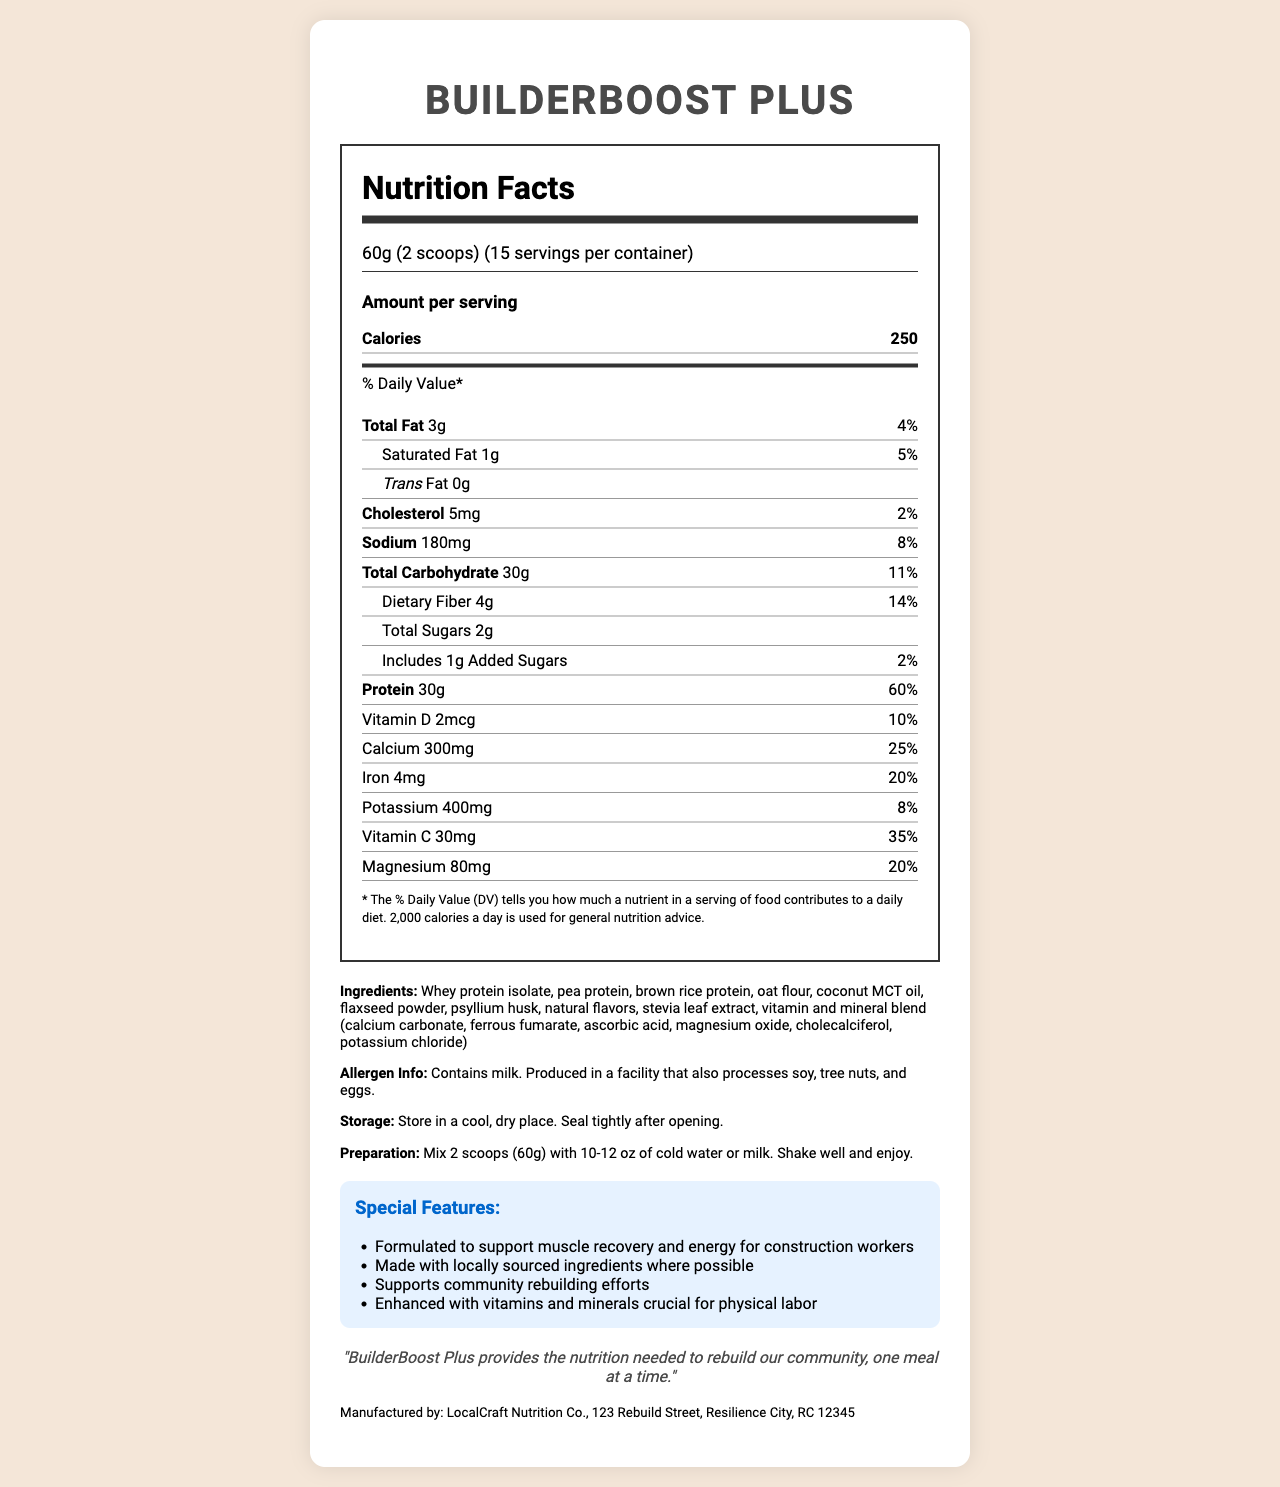what is the serving size of BuilderBoost Plus? The serving size is mentioned clearly in the document: "60g (2 scoops)."
Answer: 60g (2 scoops) how many calories does one serving of BuilderBoost Plus contain? The caloric content per serving is shown: "Calories 250."
Answer: 250 calories what is the amount of protein in BuilderBoost Plus per serving? The document specifies that each serving contains "Protein: 30g."
Answer: 30g what percentage of the daily value of Vitamin D does BuilderBoost Plus provide per serving? It is listed in the document: "Vitamin D: 2mcg, 10% Daily Value."
Answer: 10% what is the manufacturer of BuilderBoost Plus? The manufacturer name is provided under the manufacturer section: "LocalCraft Nutrition Co."
Answer: LocalCraft Nutrition Co. which nutrient's daily value is the highest in BuilderBoost Plus? A. Iron B. Calcium C. Protein The daily value percentages for Iron, Calcium, and Protein are 20%, 25%, and 60% respectively. The highest percentage is for Protein.
Answer: C which special feature does NOT belong to BuilderBoost Plus? A. Formulated to support muscle recovery B. Made with organic ingredients C. Supports community rebuilding The document does not mention that BuilderBoost Plus is made with organic ingredients. The other options are mentioned under the special features section.
Answer: B can you find the amount of trans fat in BuilderBoost Plus? yes or no The document clearly states that the trans fat content is "0g."
Answer: Yes summarize the main idea of the document. This summary captures the essence of the document focusing on the product purpose, key nutritional values, and special features that highlight its benefits.
Answer: BuilderBoost Plus is a protein-rich meal supplement designed to support construction workers. It contains a mix of proteins and is enhanced with essential vitamins and minerals. The supplement is formulated to aid muscle recovery and energy, using locally sourced ingredients where possible, and supports community rebuilding efforts. The nutrition facts label provides detailed information on serving size, nutritional content, and components. how long can you store BuilderBoost Plus after opening? The document only advises to store in a cool, dry place and to seal tightly after opening but does not specify a duration.
Answer: Not enough information how much dietary fiber is included per serving? The dietary fiber amount per serving is mentioned: "Dietary Fiber: 4g."
Answer: 4g what are the key ingredients in BuilderBoost Plus? The ingredients are listed under the ingredients section of the document.
Answer: Whey protein isolate, pea protein, brown rice protein, oat flour, coconut MCT oil, flaxseed powder, psyllium husk, natural flavors, stevia leaf extract, vitamin and mineral blend does BuilderBoost Plus contain any allergens? The allergen information section states that it contains milk and is produced in a facility that also processes soy, tree nuts, and eggs.
Answer: Yes what is the total carbohydrate content per serving? The document mentions: "Total Carbohydrate: 30g."
Answer: 30g what is the address of the manufacturer? The address is provided under the manufacturer section: "123 Rebuild Street, Resilience City, RC 12345."
Answer: 123 Rebuild Street, Resilience City, RC 12345 